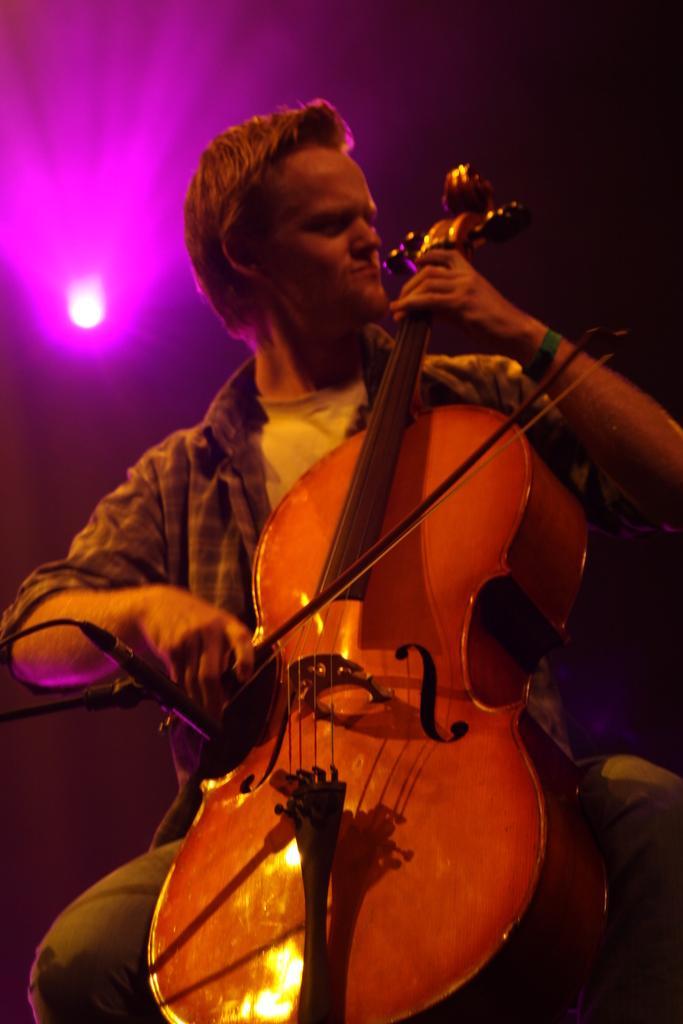How would you summarize this image in a sentence or two? In this picture a man sitting on a table and playing violin and back side we can see light focusing 